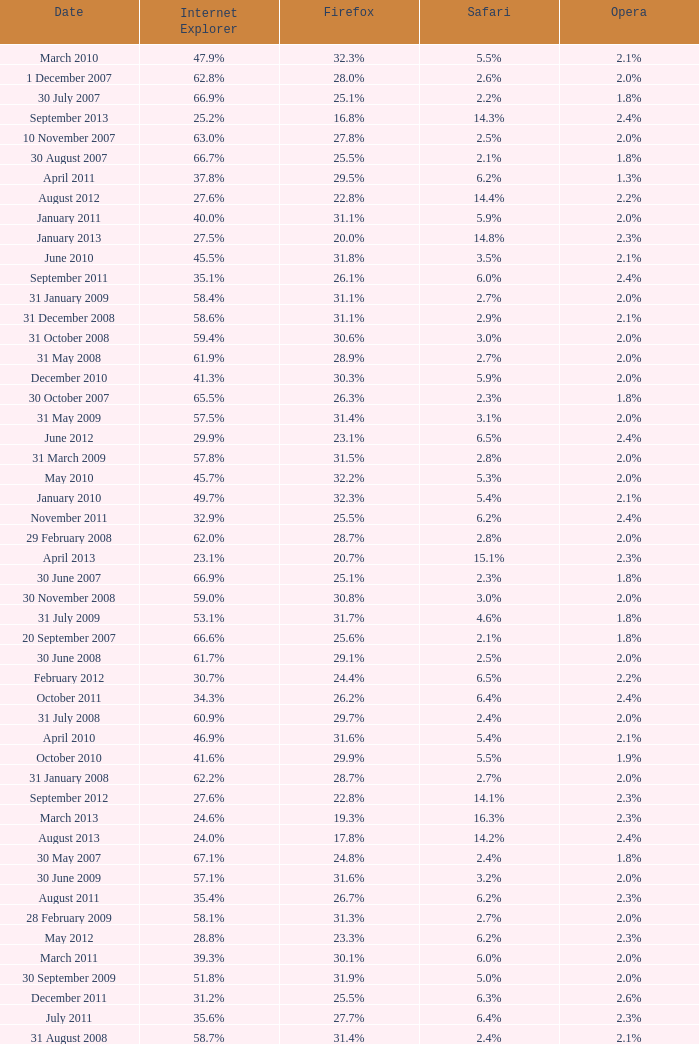What is the firefox value with a 1.8% opera on 30 July 2007? 25.1%. 